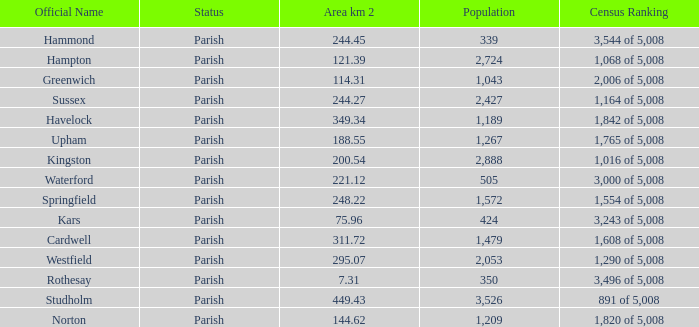What is the area in square kilometers of Studholm? 1.0. 